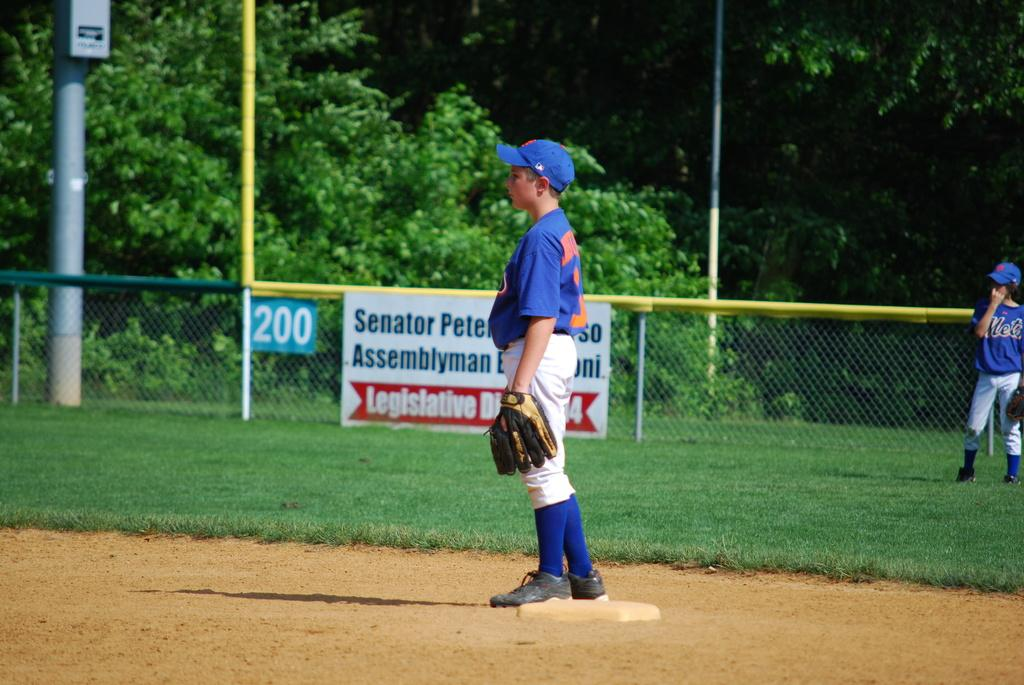<image>
Describe the image concisely. A kid is standing out in a baseball field in front of a sign saying 200 